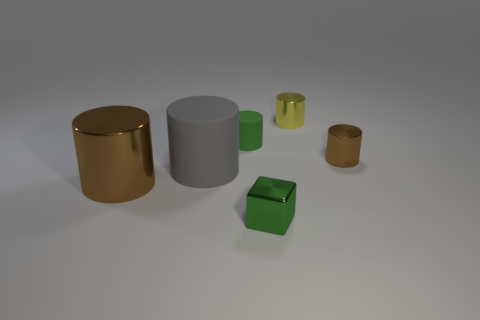Subtract all big cylinders. How many cylinders are left? 3 Subtract all green cylinders. How many cylinders are left? 4 Subtract all blocks. How many objects are left? 5 Subtract 1 blocks. How many blocks are left? 0 Add 3 gray rubber cylinders. How many objects exist? 9 Subtract all small green objects. Subtract all gray cylinders. How many objects are left? 3 Add 2 small yellow objects. How many small yellow objects are left? 3 Add 6 large brown metallic things. How many large brown metallic things exist? 7 Subtract 1 green cubes. How many objects are left? 5 Subtract all cyan cylinders. Subtract all green cubes. How many cylinders are left? 5 